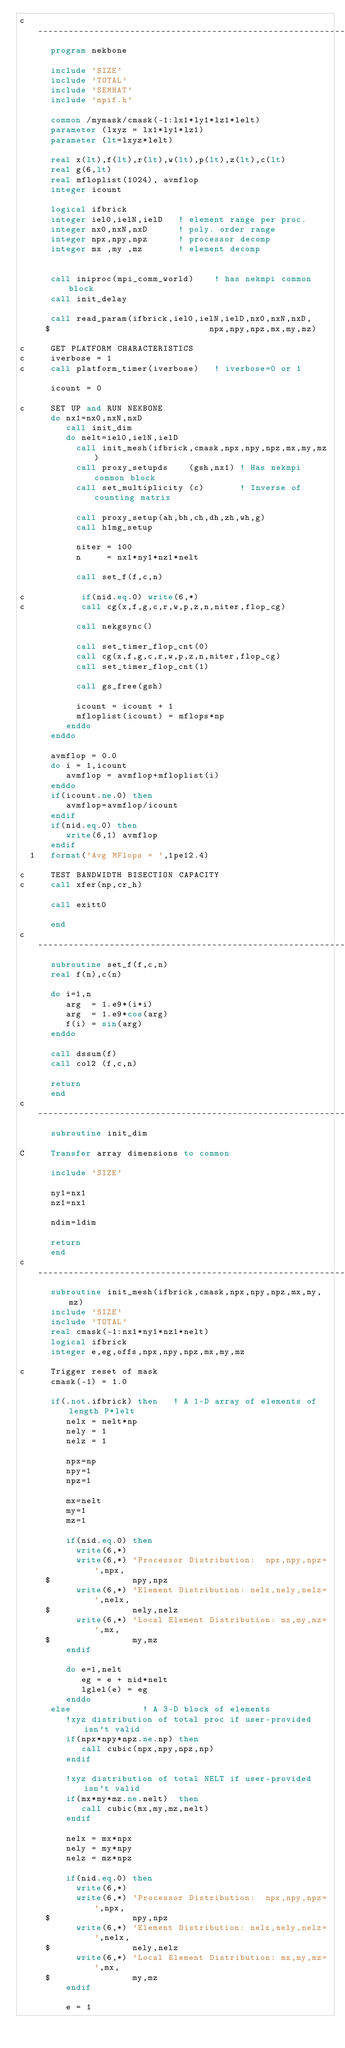<code> <loc_0><loc_0><loc_500><loc_500><_FORTRAN_>c-----------------------------------------------------------------------
      program nekbone
      
      include 'SIZE'
      include 'TOTAL'
      include 'SEMHAT'
      include 'mpif.h'

      common /mymask/cmask(-1:lx1*ly1*lz1*lelt)
      parameter (lxyz = lx1*ly1*lz1)
      parameter (lt=lxyz*lelt)

      real x(lt),f(lt),r(lt),w(lt),p(lt),z(lt),c(lt)
      real g(6,lt)
      real mfloplist(1024), avmflop
      integer icount  

      logical ifbrick
      integer iel0,ielN,ielD   ! element range per proc.
      integer nx0,nxN,nxD      ! poly. order range
      integer npx,npy,npz      ! processor decomp
      integer mx ,my ,mz       ! element decomp


      call iniproc(mpi_comm_world)    ! has nekmpi common block
      call init_delay

      call read_param(ifbrick,iel0,ielN,ielD,nx0,nxN,nxD,
     $                               npx,npy,npz,mx,my,mz)

c     GET PLATFORM CHARACTERISTICS
c     iverbose = 1
c     call platform_timer(iverbose)   ! iverbose=0 or 1

      icount = 0

c     SET UP and RUN NEKBONE
      do nx1=nx0,nxN,nxD
         call init_dim
         do nelt=iel0,ielN,ielD
           call init_mesh(ifbrick,cmask,npx,npy,npz,mx,my,mz)
           call proxy_setupds    (gsh,nx1) ! Has nekmpi common block
           call set_multiplicity (c)       ! Inverse of counting matrix

           call proxy_setup(ah,bh,ch,dh,zh,wh,g) 
           call h1mg_setup

           niter = 100
           n     = nx1*ny1*nz1*nelt

           call set_f(f,c,n)

c           if(nid.eq.0) write(6,*)
c           call cg(x,f,g,c,r,w,p,z,n,niter,flop_cg)

           call nekgsync()

           call set_timer_flop_cnt(0)
           call cg(x,f,g,c,r,w,p,z,n,niter,flop_cg)
           call set_timer_flop_cnt(1)

           call gs_free(gsh)
           
           icount = icount + 1
           mfloplist(icount) = mflops*np
         enddo
      enddo

      avmflop = 0.0
      do i = 1,icount
         avmflop = avmflop+mfloplist(i)
      enddo
      if(icount.ne.0) then
         avmflop=avmflop/icount
      endif
      if(nid.eq.0) then
         write(6,1) avmflop
      endif
  1   format('Avg MFlops = ',1pe12.4)

c     TEST BANDWIDTH BISECTION CAPACITY
c     call xfer(np,cr_h)

      call exitt0

      end
c--------------------------------------------------------------
      subroutine set_f(f,c,n)
      real f(n),c(n)

      do i=1,n
         arg  = 1.e9*(i*i)
         arg  = 1.e9*cos(arg)
         f(i) = sin(arg)
      enddo

      call dssum(f)
      call col2 (f,c,n)

      return
      end
c-----------------------------------------------------------------------
      subroutine init_dim

C     Transfer array dimensions to common

      include 'SIZE'
 
      ny1=nx1
      nz1=nx1
 
      ndim=ldim

      return
      end
c-----------------------------------------------------------------------
      subroutine init_mesh(ifbrick,cmask,npx,npy,npz,mx,my,mz)
      include 'SIZE'
      include 'TOTAL'
      real cmask(-1:nx1*ny1*nz1*nelt)
      logical ifbrick
      integer e,eg,offs,npx,npy,npz,mx,my,mz
 
c     Trigger reset of mask
      cmask(-1) = 1.0

      if(.not.ifbrick) then   ! A 1-D array of elements of length P*lelt
         nelx = nelt*np
         nely = 1
         nelz = 1

         npx=np
         npy=1
         npz=1

         mx=nelt
         my=1
         mz=1

         if(nid.eq.0) then 
           write(6,*)
           write(6,*) 'Processor Distribution:  npx,npy,npz=',npx,
     $                npy,npz
           write(6,*) 'Element Distribution: nelx,nely,nelz=',nelx,
     $                nely,nelz
           write(6,*) 'Local Element Distribution: mx,my,mz=',mx,
     $                my,mz
         endif
   
         do e=1,nelt
            eg = e + nid*nelt
            lglel(e) = eg
         enddo
      else              ! A 3-D block of elements 
         !xyz distribution of total proc if user-provided isn't valid
         if(npx*npy*npz.ne.np) then
            call cubic(npx,npy,npz,np) 
         endif

         !xyz distribution of total NELT if user-provided isn't valid
         if(mx*my*mz.ne.nelt)  then
            call cubic(mx,my,mz,nelt) 
         endif
      
         nelx = mx*npx
         nely = my*npy 
         nelz = mz*npz

         if(nid.eq.0) then 
           write(6,*)
           write(6,*) 'Processor Distribution:  npx,npy,npz=',npx,
     $                npy,npz
           write(6,*) 'Element Distribution: nelx,nely,nelz=',nelx,
     $                nely,nelz
           write(6,*) 'Local Element Distribution: mx,my,mz=',mx,
     $                my,mz
         endif

         e = 1</code> 